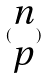<formula> <loc_0><loc_0><loc_500><loc_500>( \begin{matrix} n \\ p \end{matrix} )</formula> 